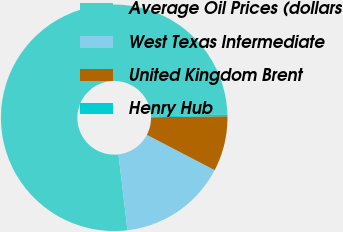<chart> <loc_0><loc_0><loc_500><loc_500><pie_chart><fcel>Average Oil Prices (dollars<fcel>West Texas Intermediate<fcel>United Kingdom Brent<fcel>Henry Hub<nl><fcel>76.38%<fcel>15.48%<fcel>7.87%<fcel>0.26%<nl></chart> 